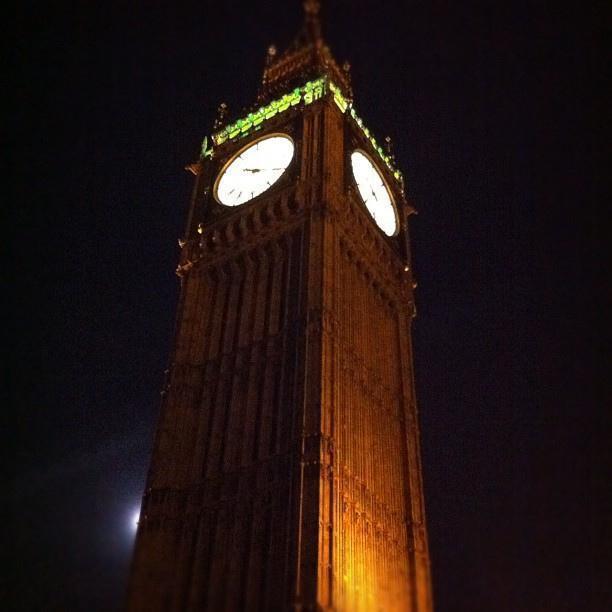How many spires are visible?
Give a very brief answer. 1. How many clocks are there?
Give a very brief answer. 2. 